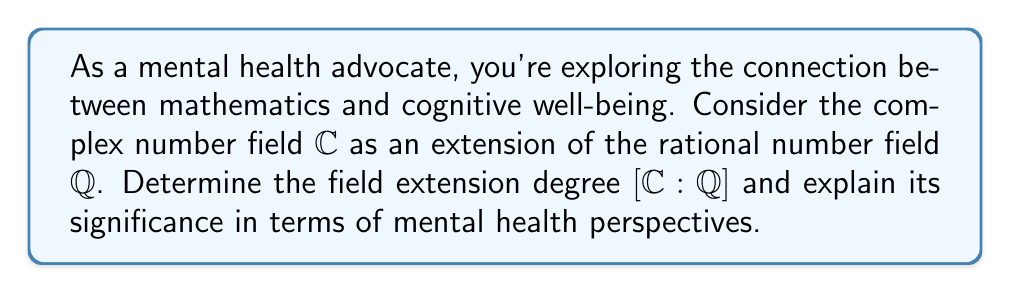Can you solve this math problem? Let's approach this step-by-step:

1) First, recall that the field extension degree $[F:K]$ is the dimension of $F$ as a vector space over $K$.

2) To determine $[\mathbb{C}:\mathbb{Q}]$, we need to find a basis for $\mathbb{C}$ over $\mathbb{Q}$.

3) Every complex number can be written in the form $a + bi$, where $a$ and $b$ are real numbers and $i$ is the imaginary unit with $i^2 = -1$.

4) However, we need to express this in terms of rational numbers. We can write:
   $$z = q_1 + q_2i$$
   where $q_1, q_2 \in \mathbb{Q}$.

5) This shows that $\{1, i\}$ forms a basis for $\mathbb{C}$ over $\mathbb{Q}$.

6) The number of elements in this basis is 2, therefore:
   $$[\mathbb{C}:\mathbb{Q}] = 2$$

7) From a mental health perspective, this result can be interpreted as follows:
   - The rational numbers represent logical, structured thinking.
   - The imaginary unit $i$ represents creativity, emotions, or abstract thinking.
   - The fact that any complex number can be expressed using these two components parallels the idea of balanced mental health, where both logical and emotional aspects are integrated.

8) The field extension degree of 2 suggests that to fully describe our mental state (the "complex" state), we need both rational and emotional components, neither more nor less.
Answer: $[\mathbb{C}:\mathbb{Q}] = 2$ 